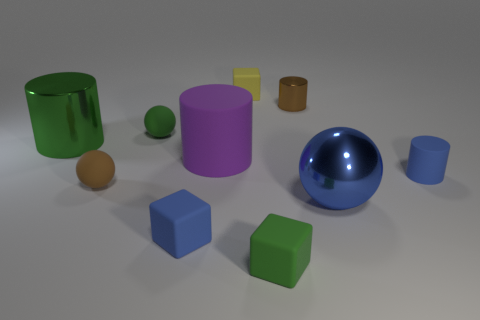Is there a blue ball of the same size as the yellow block?
Your answer should be compact. No. What material is the brown object to the right of the small yellow matte thing?
Provide a succinct answer. Metal. What color is the cylinder that is the same material as the big purple object?
Your answer should be compact. Blue. How many rubber things are tiny yellow objects or large cyan things?
Provide a short and direct response. 1. The yellow object that is the same size as the brown metallic cylinder is what shape?
Ensure brevity in your answer.  Cube. How many things are either tiny blue objects that are on the right side of the big sphere or blue matte objects left of the blue cylinder?
Offer a very short reply. 2. There is a yellow block that is the same size as the green matte block; what is it made of?
Give a very brief answer. Rubber. What number of other objects are there of the same material as the small yellow object?
Make the answer very short. 6. Is the number of matte things that are on the right side of the green matte ball the same as the number of shiny cylinders in front of the big purple matte thing?
Your answer should be compact. No. How many green objects are small metallic things or tiny matte spheres?
Offer a very short reply. 1. 